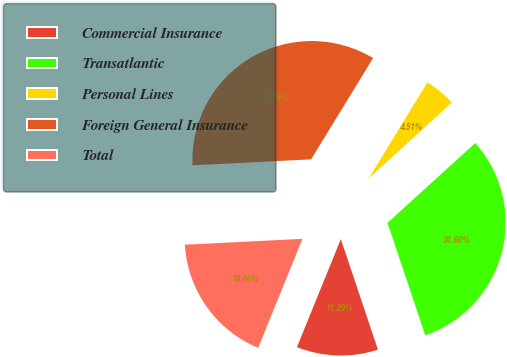Convert chart. <chart><loc_0><loc_0><loc_500><loc_500><pie_chart><fcel>Commercial Insurance<fcel>Transatlantic<fcel>Personal Lines<fcel>Foreign General Insurance<fcel>Total<nl><fcel>11.29%<fcel>31.6%<fcel>4.51%<fcel>34.54%<fcel>18.06%<nl></chart> 